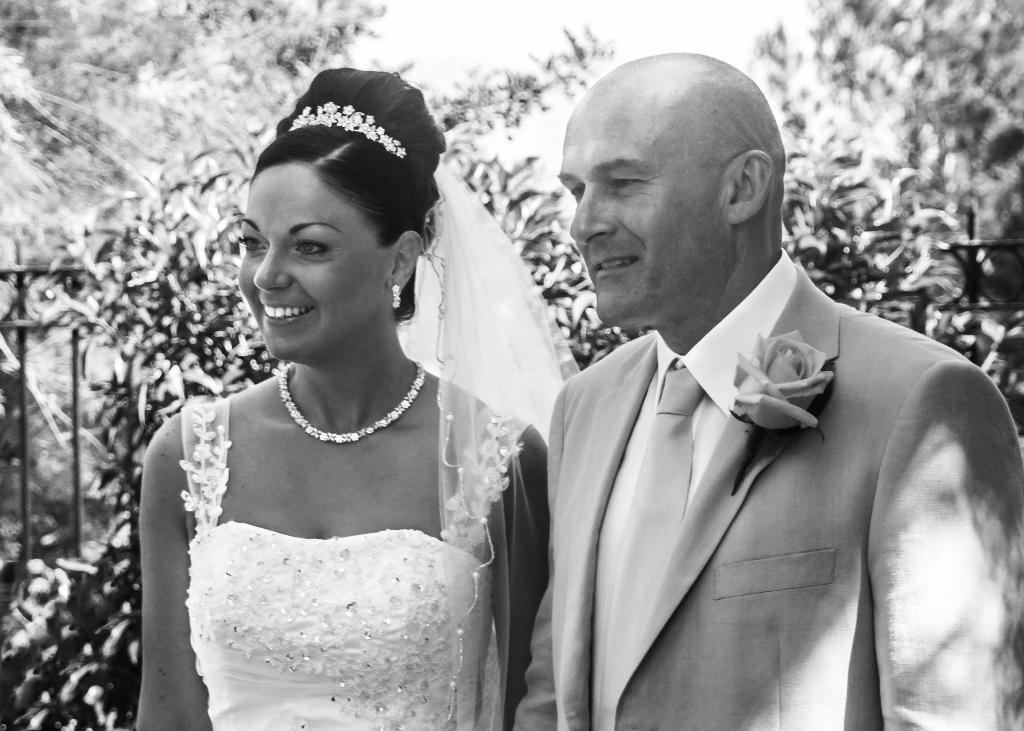How would you summarize this image in a sentence or two? In this picture we can see two people smiling, some objects and in the background we can see fence, trees. 